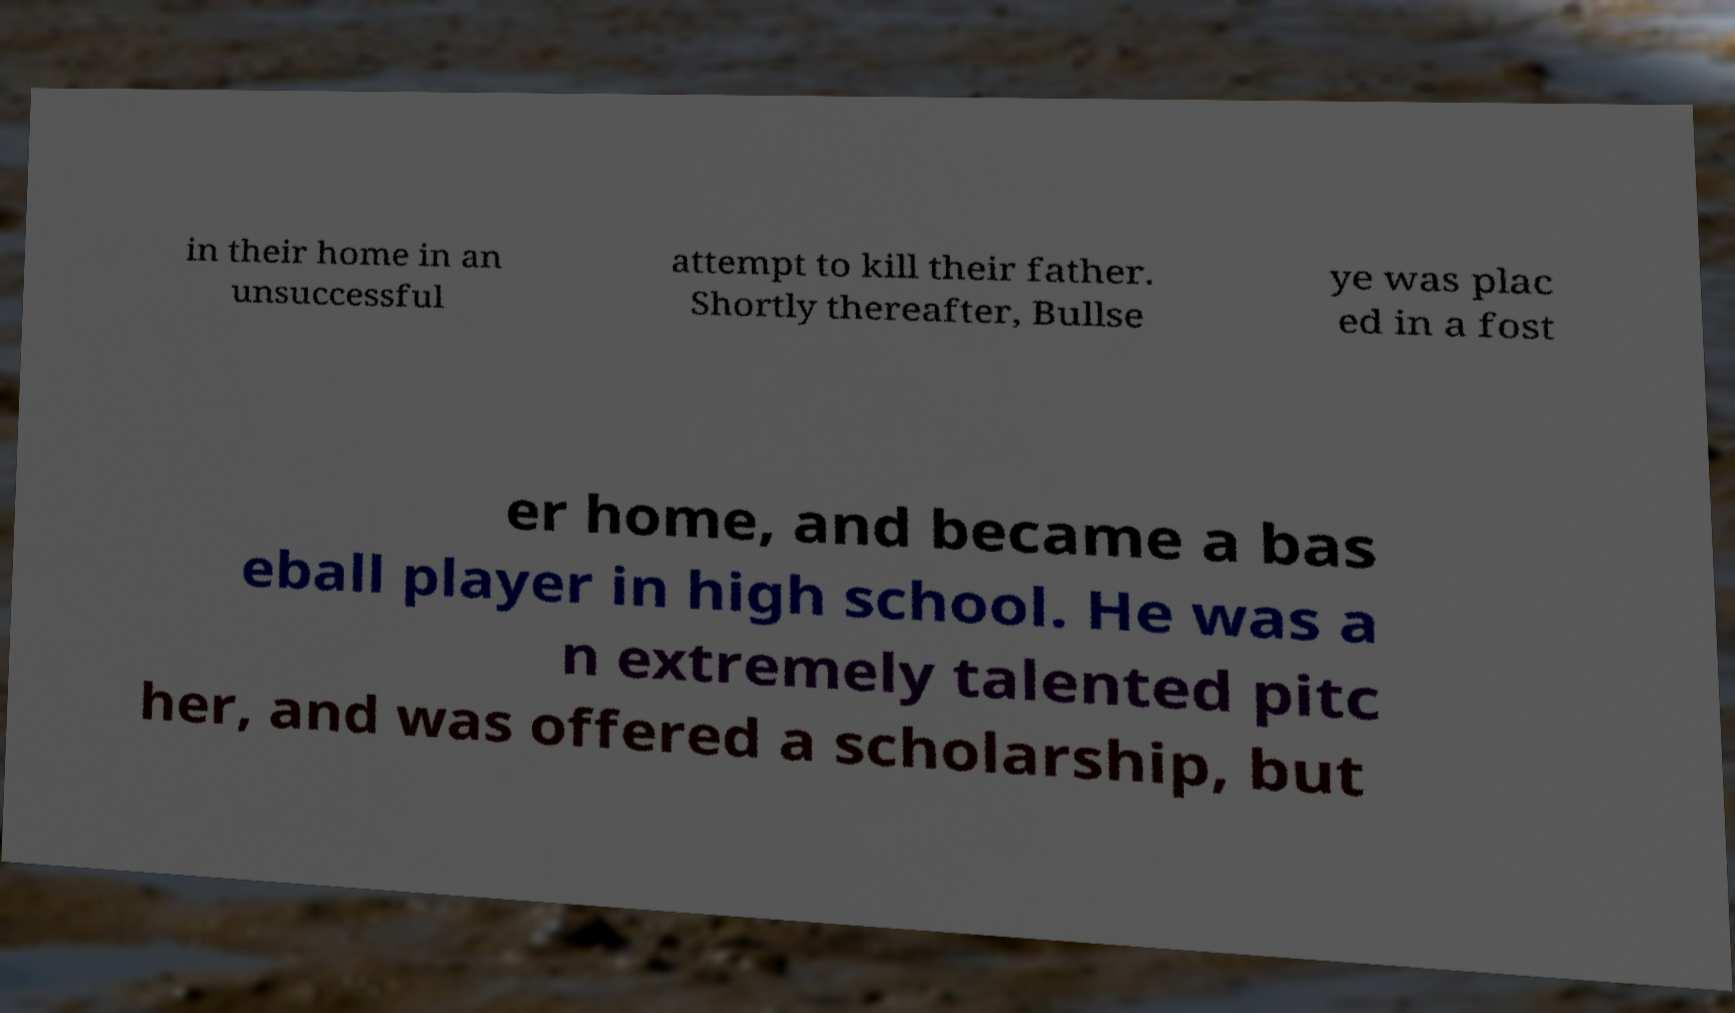Could you assist in decoding the text presented in this image and type it out clearly? in their home in an unsuccessful attempt to kill their father. Shortly thereafter, Bullse ye was plac ed in a fost er home, and became a bas eball player in high school. He was a n extremely talented pitc her, and was offered a scholarship, but 